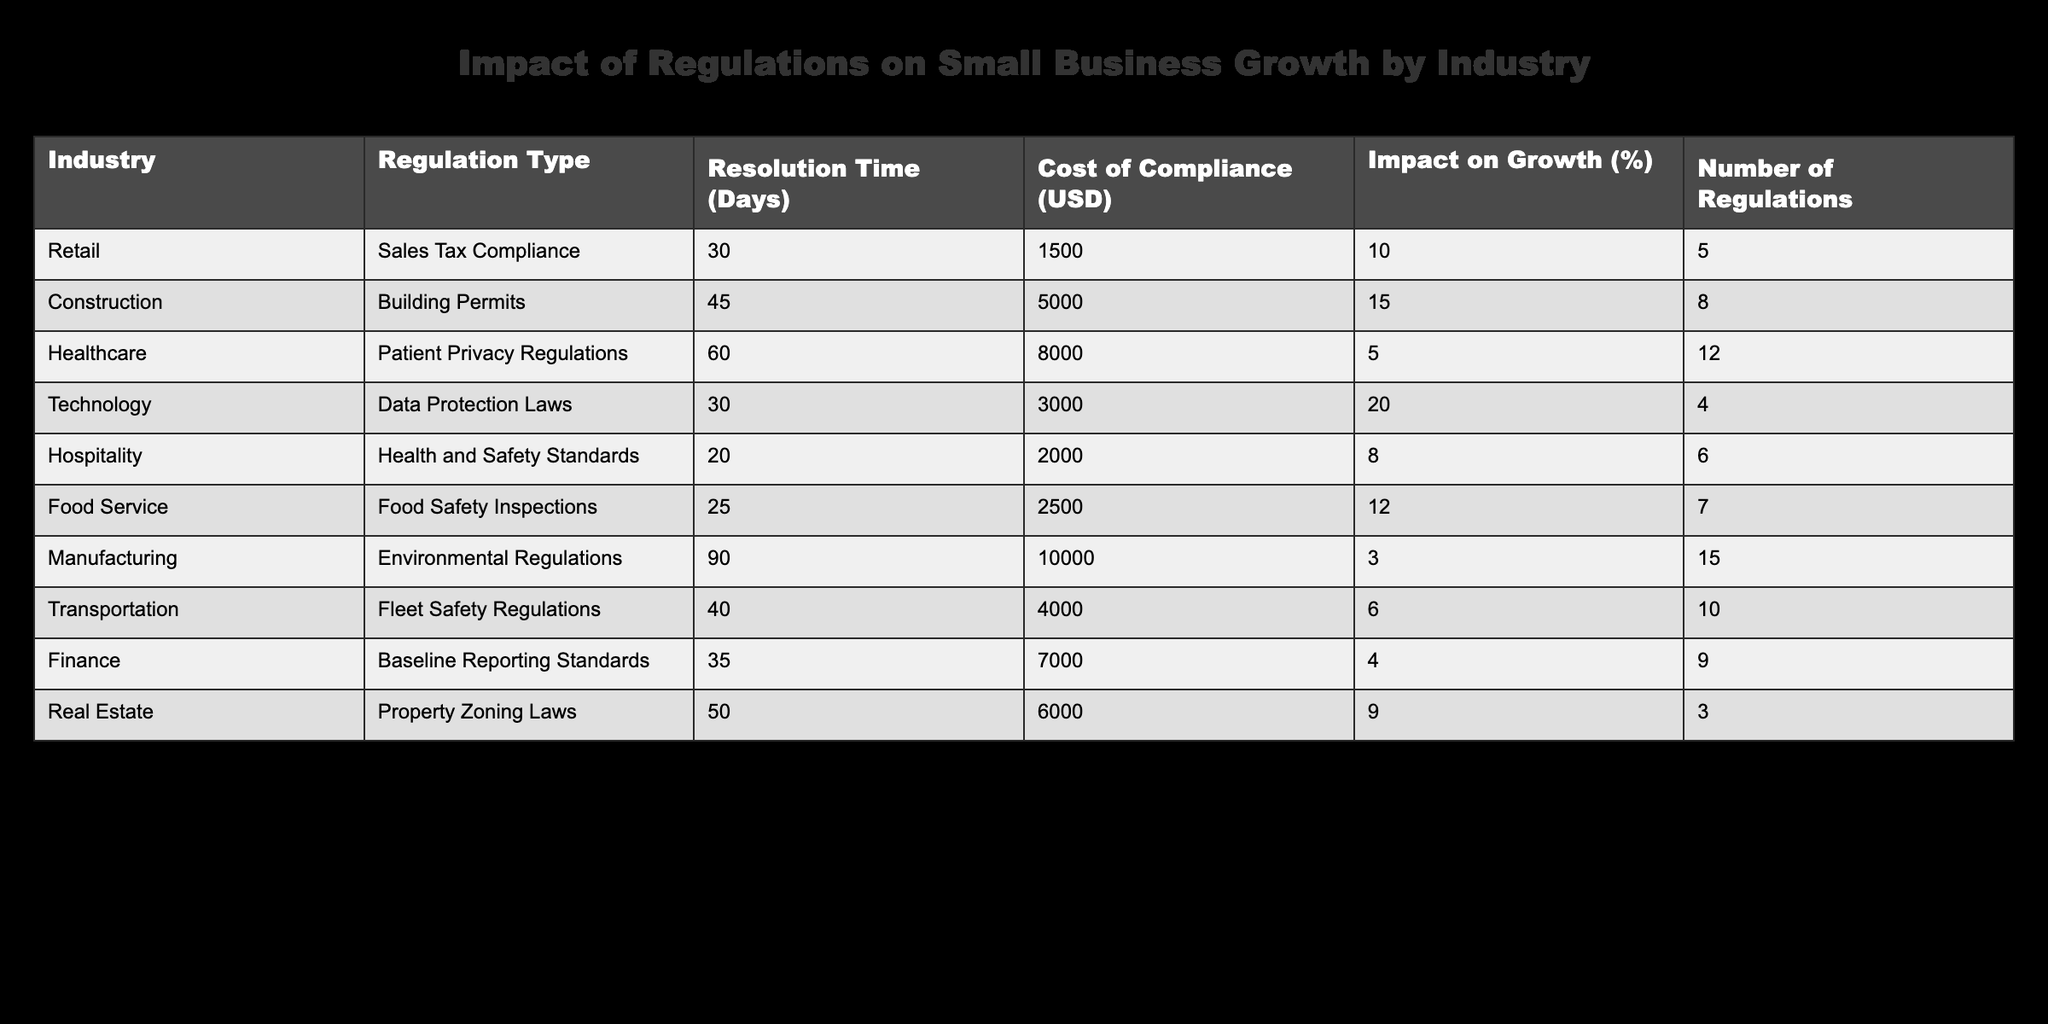What is the cost of compliance for the Healthcare industry? The table shows the cost of compliance under the column 'Cost of Compliance (USD)' for each industry. For the Healthcare industry, the value listed is 8000.
Answer: 8000 How many regulations apply to the Retail industry? Referring to the table, in the 'Number of Regulations' column for the Retail industry, the value listed is 5.
Answer: 5 Which industry has the longest resolution time for regulations? The table lists the 'Resolution Time (Days)' for each industry. Upon comparison, the Manufacturing industry has the longest resolution time of 90 days.
Answer: Manufacturing What is the average impact on growth for the Technology and Food Service industries combined? To find the average, first identify the impact on growth for both industries: Technology has 20% and Food Service has 12%. So, the sum is 20 + 12 = 32, and the average is then 32 / 2 = 16.
Answer: 16 Are there more regulations affecting the Transportation industry compared to the Hospitality industry? Looking at the table, the Transportation industry has 10 regulations, while the Hospitality industry has 6 regulations. So, Transportation has more regulations than Hospitality.
Answer: Yes What is the difference in cost of compliance between the Construction and Manufacturing industries? From the table, the cost of compliance for Construction is 5000, and for Manufacturing, it is 10000. Thus, the difference is 10000 - 5000 = 5000.
Answer: 5000 Which industry has the highest percentage impact on growth? By examining the 'Impact on Growth (%)' column, the Technology industry shows the highest percentage impact at 20%.
Answer: Technology Is the average resolution time for the Healthcare and Finance industries less than 50 days? The resolution times are 60 days for Healthcare and 35 days for Finance. The average is calculated as (60 + 35) / 2 = 47.5, which is less than 50.
Answer: Yes Which industry has the lowest impact on growth, and what is it? The 'Impact on Growth (%)' column shows that the Manufacturing industry has the lowest impact at 3%.
Answer: Manufacturing, 3% 